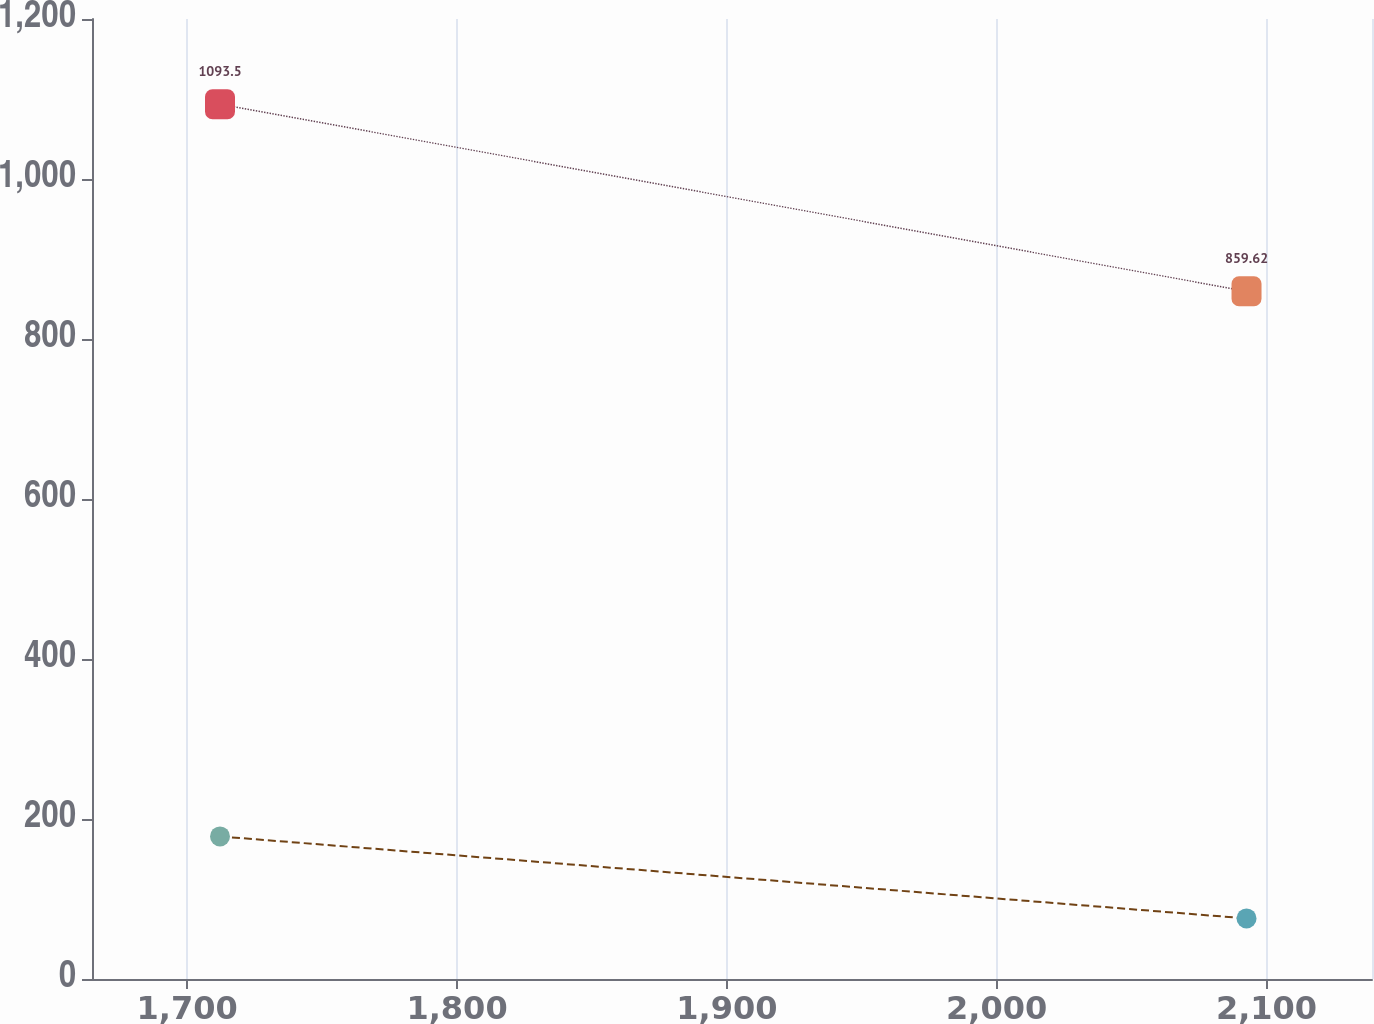Convert chart. <chart><loc_0><loc_0><loc_500><loc_500><line_chart><ecel><fcel>Accounts<fcel>Expense<nl><fcel>1712.15<fcel>1093.5<fcel>178.2<nl><fcel>2092.59<fcel>859.62<fcel>75.76<nl><fcel>2186.53<fcel>781.56<fcel>41.08<nl></chart> 